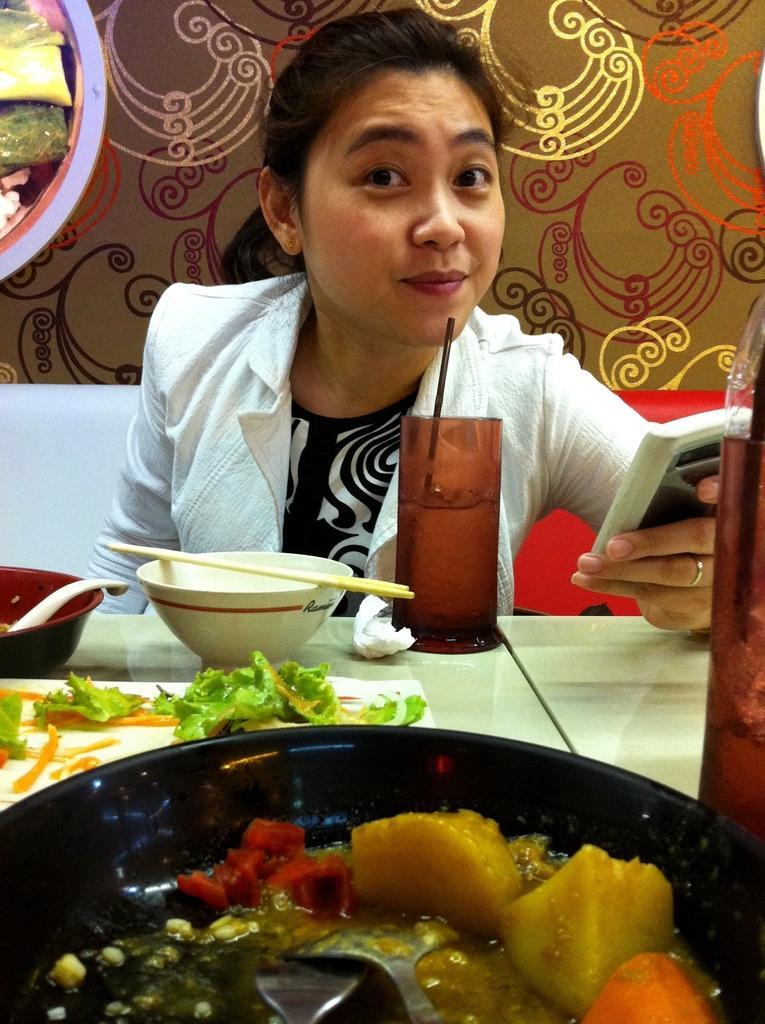Describe this image in one or two sentences. In this image I can see a girl is sitting, holding the mobile phone in her hand. She wore white color sweater, there are food items on this dining table. 